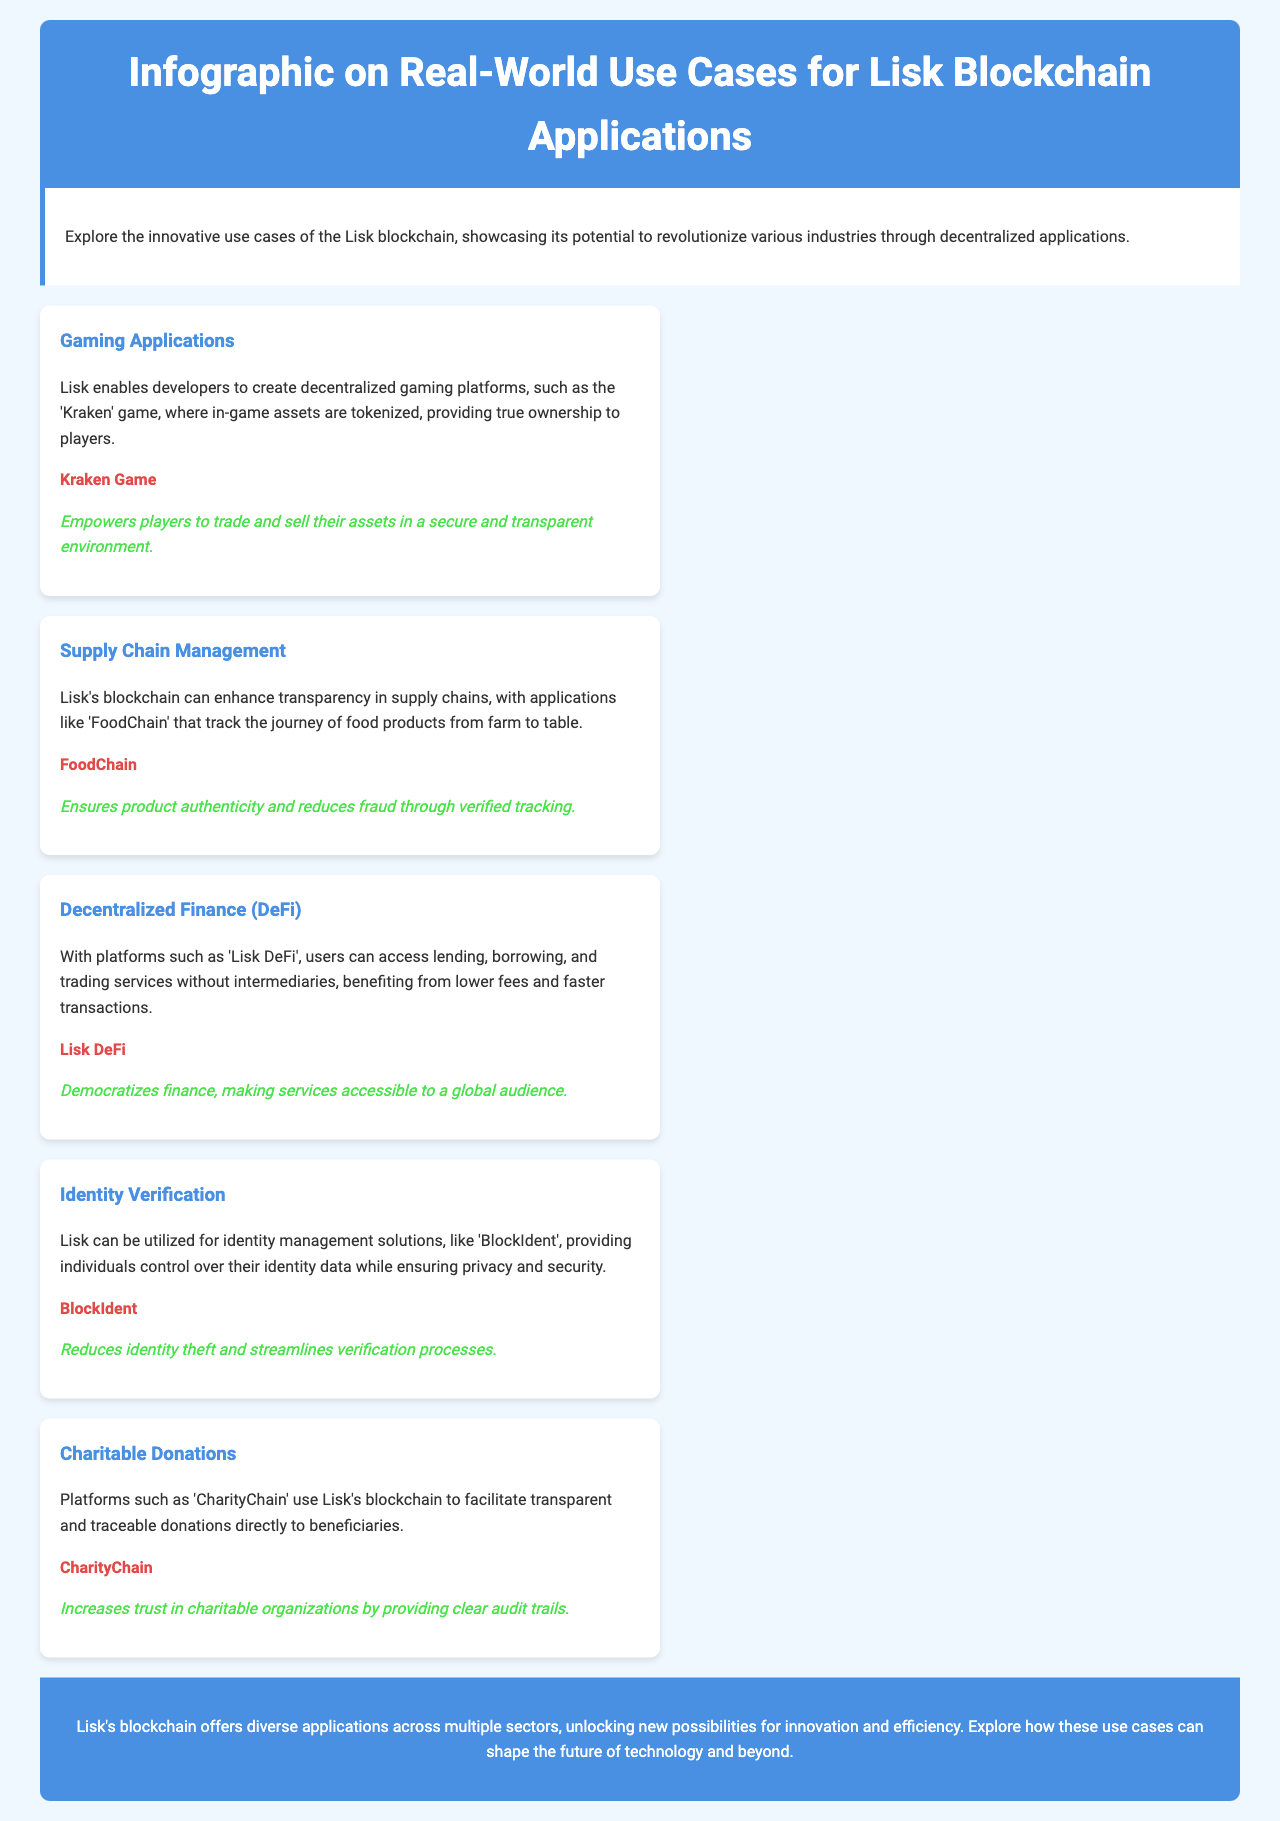What is the title of the document? The title is prominently displayed at the top of the document, identifying its main subject.
Answer: Infographic on Real-World Use Cases for Lisk Blockchain Applications What is one of the gaming applications mentioned? The document lists the 'Kraken' game as an example of a gaming application powered by Lisk.
Answer: Kraken Game What benefit does 'FoodChain' provide? The document states that 'FoodChain' enhances product authenticity and reduces fraud through verified tracking.
Answer: Ensures product authenticity and reduces fraud What sector does 'Lisk DeFi' belong to? The document classifies 'Lisk DeFi' under Decentralized Finance applications.
Answer: Decentralized Finance (DeFi) What is the main purpose of 'CharityChain'? According to the document, 'CharityChain' facilitates transparent and traceable donations directly to beneficiaries.
Answer: Facilitates transparent and traceable donations What technology does Lisk aim to enhance in supply chains? The focus in the document indicates that Lisk aims to enhance transparency in supply chains.
Answer: Transparency What does 'BlockIdent' help reduce? The document highlights that 'BlockIdent' reduces identity theft as per its application description.
Answer: Identity theft What is a common theme across the use cases presented? The document repeatedly emphasizes the importance of security and transparency as prevalent themes.
Answer: Security and transparency 